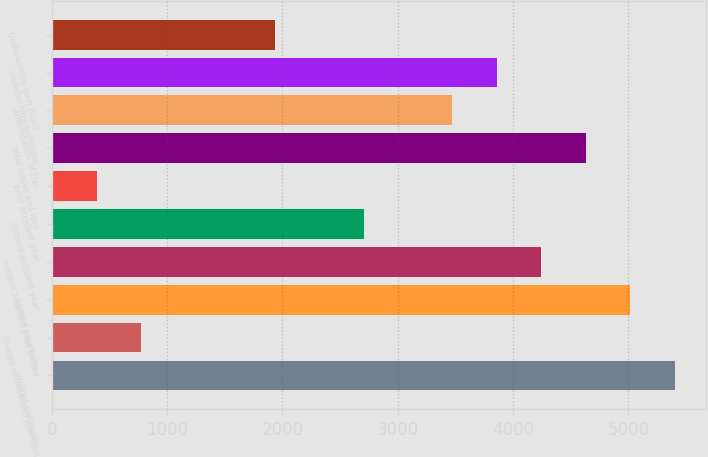Convert chart. <chart><loc_0><loc_0><loc_500><loc_500><bar_chart><fcel>Written premiums<fcel>change in unearned premium<fcel>earned premiums<fcel>current accident year before<fcel>current accident year<fcel>prior accident year<fcel>total losses and loss<fcel>amortization of Dac<fcel>underwriting expenses<fcel>Underwriting gain (loss)<nl><fcel>5403.4<fcel>776.2<fcel>5017.8<fcel>4246.6<fcel>2704.2<fcel>390.6<fcel>4632.2<fcel>3475.4<fcel>3861<fcel>1933<nl></chart> 